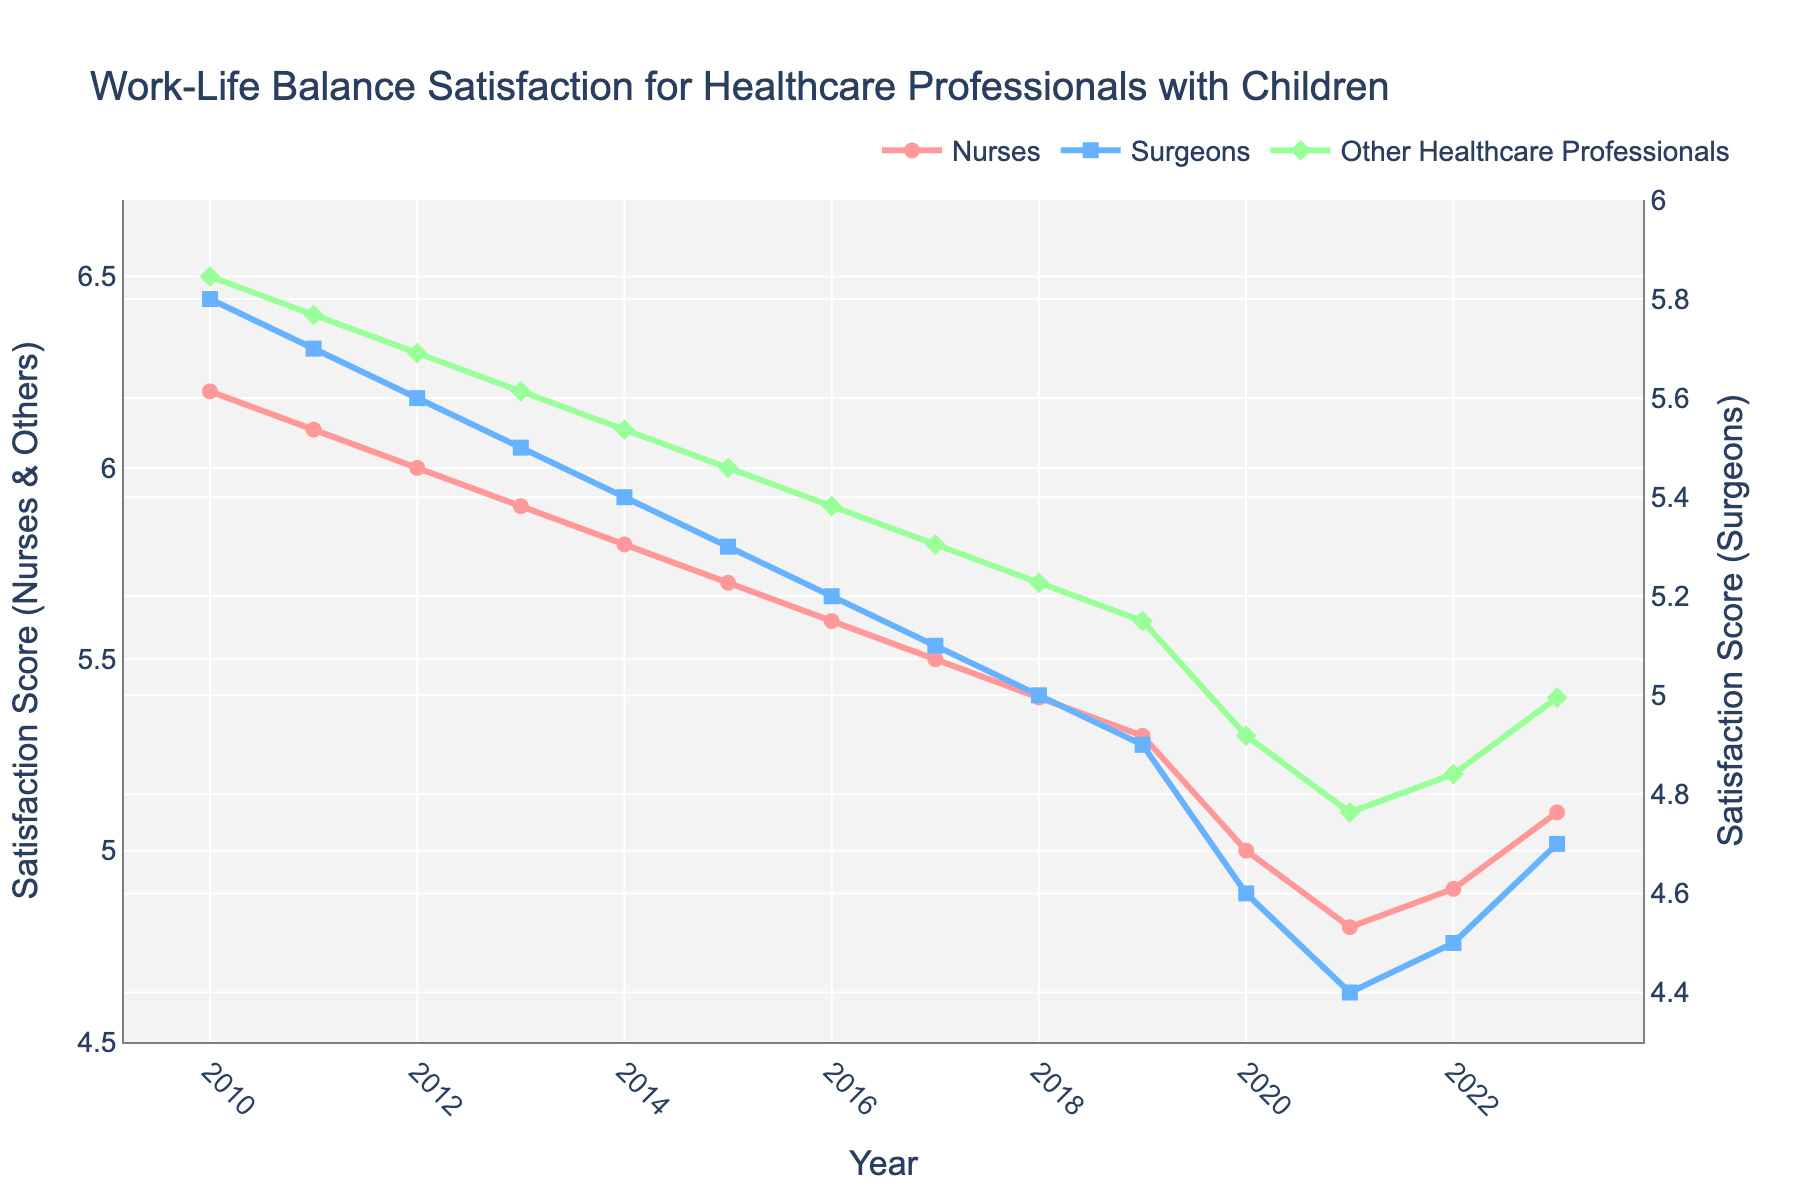How did the satisfaction scores for nurses change from 2010 to 2023? To find the change in satisfaction scores for nurses from 2010 to 2023, subtract the 2010 score from the 2023 score: 5.1 (2023) - 6.2 (2010) = -1.1. This shows a decrease of 1.1 points.
Answer: Decreased by 1.1 Which group experienced the steepest decline in satisfaction scores from 2010 to 2021? To find the steepest decline, compare the changes for each group from 2010 to 2021: Nurses: 4.8 - 6.2 = -1.4, Surgeons: 4.4 - 5.8 = -1.4, Other Healthcare Professionals: 5.1 - 6.5 = -1.4. All groups declined equally by 1.4 points.
Answer: All groups equally What was the lowest satisfaction score recorded for surgeons, and in which year did it occur? To find this, look for the minimum value in the `Surgeons` line: The lowest score is 4.4 in 2021.
Answer: 4.4 in 2021 Compare the satisfaction scores of surgeons and other healthcare professionals in 2022. Which group had a higher score? Look at the 2022 values: Surgeons scored 4.5, and other healthcare professionals scored 5.2. Other healthcare professionals had a higher score.
Answer: Other healthcare professionals What is the average satisfaction score for nurses over the period 2010-2023? To find the average, add all the satisfaction scores for nurses from 2010 to 2023 and divide by the number of years: (6.2 + 6.1 + 6.0 + 5.9 + 5.8 + 5.7 + 5.6 + 5.5 + 5.4 + 5.3 + 5.0 + 4.8 + 4.9 + 5.1) / 14 = 5.57 (rounded to two decimal places).
Answer: 5.57 Between which consecutive years did nurses experience the sharpest decline in satisfaction scores? Evaluate the year-to-year differences for nurses: The sharpest decline was from 2019-2020 (5.3 - 5.0 = -0.3).
Answer: 2019 to 2020 Visually, which group has the most prominent trend line and what color is it? The `Other Healthcare Professionals` trend line is the most prominent due to its distinct diamond markers and green color.
Answer: Other Healthcare Professionals, green In which year did all three groups show a trend toward improvement after a consistent decline? By tracking the trend lines, we notice that all three groups show improvement starting from 2021 to 2023.
Answer: 2021 What was the total combined satisfaction score of all healthcare professionals in 2015? Add the scores for each group in 2015: Nurses: 5.7, Surgeons: 5.3, Other Healthcare Professionals: 6.0. The total is 5.7 + 5.3 + 6.0 = 17.0.
Answer: 17.0 